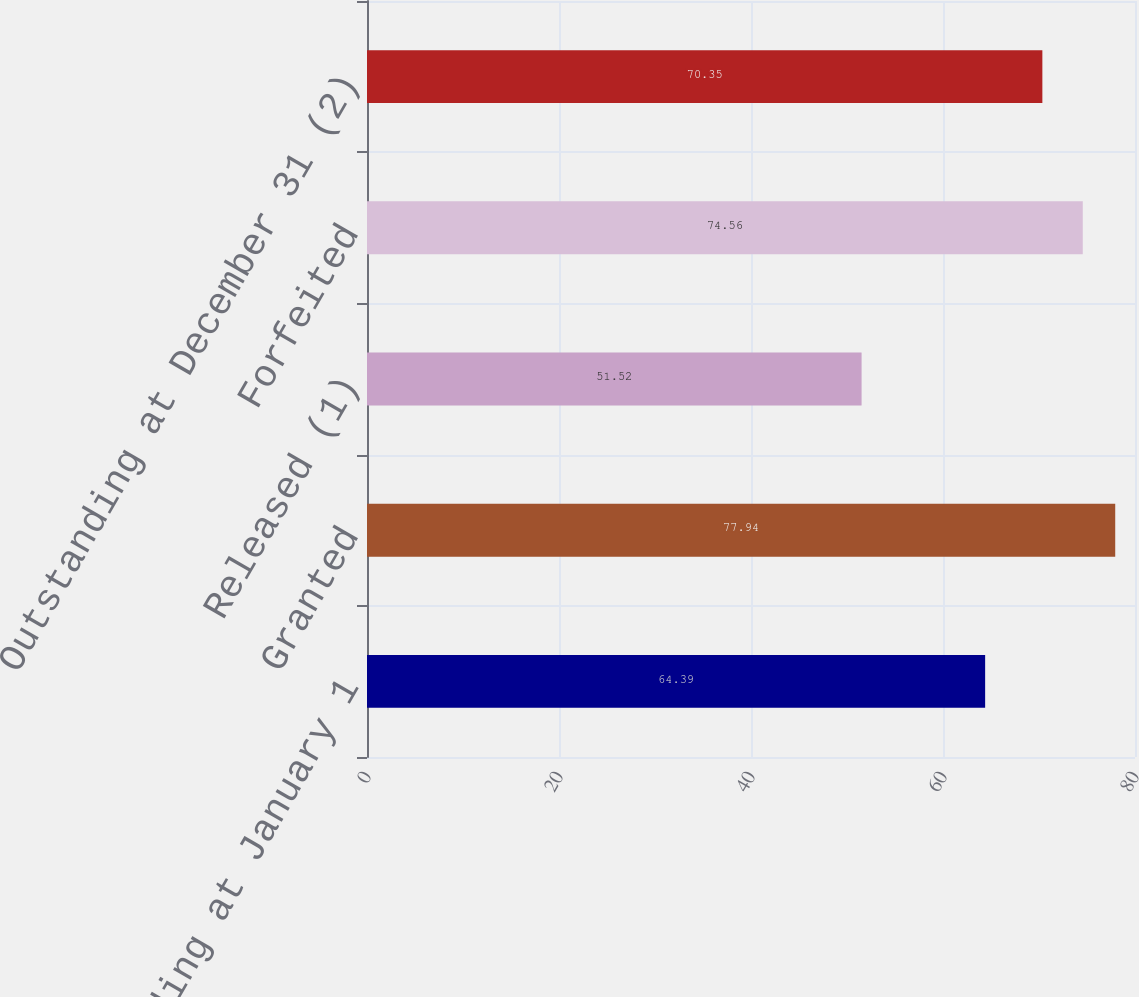Convert chart to OTSL. <chart><loc_0><loc_0><loc_500><loc_500><bar_chart><fcel>Outstanding at January 1<fcel>Granted<fcel>Released (1)<fcel>Forfeited<fcel>Outstanding at December 31 (2)<nl><fcel>64.39<fcel>77.94<fcel>51.52<fcel>74.56<fcel>70.35<nl></chart> 